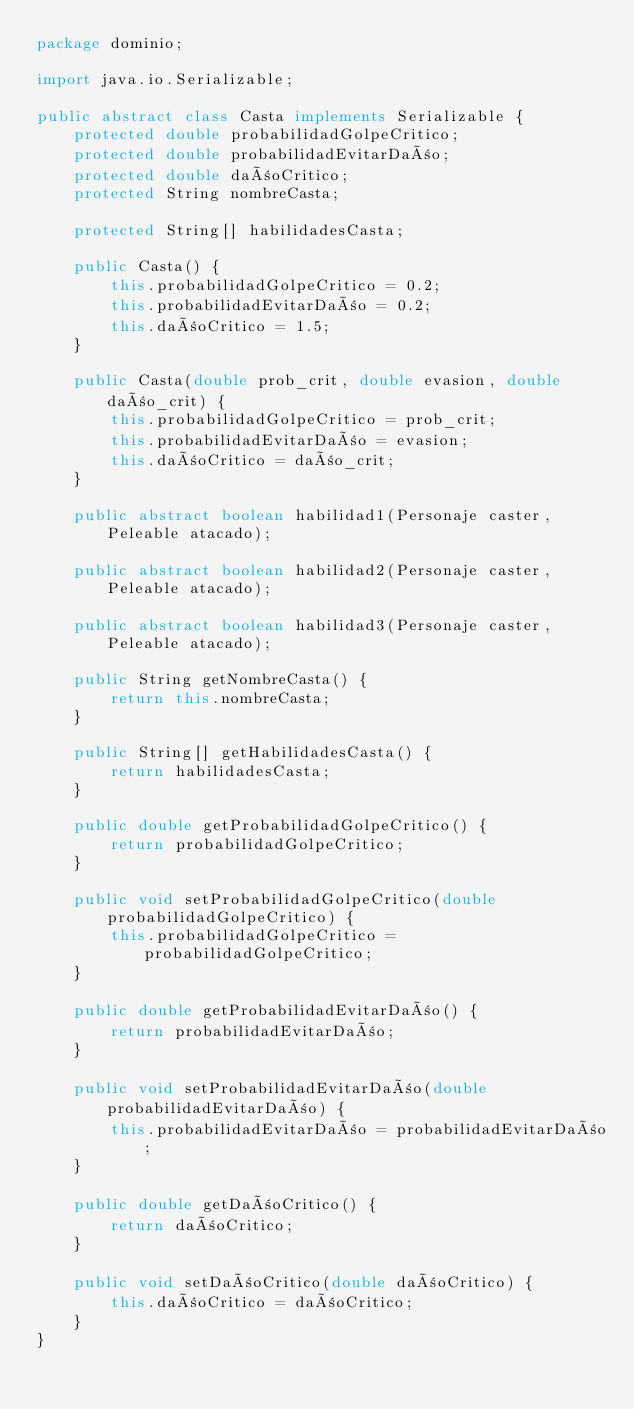Convert code to text. <code><loc_0><loc_0><loc_500><loc_500><_Java_>package dominio;

import java.io.Serializable;

public abstract class Casta implements Serializable {
	protected double probabilidadGolpeCritico;
	protected double probabilidadEvitarDaño;
	protected double dañoCritico;
	protected String nombreCasta;

	protected String[] habilidadesCasta;

	public Casta() {
		this.probabilidadGolpeCritico = 0.2;
		this.probabilidadEvitarDaño = 0.2;
		this.dañoCritico = 1.5;
	}

	public Casta(double prob_crit, double evasion, double daño_crit) {
		this.probabilidadGolpeCritico = prob_crit;
		this.probabilidadEvitarDaño = evasion;
		this.dañoCritico = daño_crit;
	}

	public abstract boolean habilidad1(Personaje caster, Peleable atacado);

	public abstract boolean habilidad2(Personaje caster, Peleable atacado);

	public abstract boolean habilidad3(Personaje caster, Peleable atacado);

	public String getNombreCasta() {
		return this.nombreCasta;
	}

	public String[] getHabilidadesCasta() {
		return habilidadesCasta;
	}

	public double getProbabilidadGolpeCritico() {
		return probabilidadGolpeCritico;
	}

	public void setProbabilidadGolpeCritico(double probabilidadGolpeCritico) {
		this.probabilidadGolpeCritico = probabilidadGolpeCritico;
	}

	public double getProbabilidadEvitarDaño() {
		return probabilidadEvitarDaño;
	}

	public void setProbabilidadEvitarDaño(double probabilidadEvitarDaño) {
		this.probabilidadEvitarDaño = probabilidadEvitarDaño;
	}

	public double getDañoCritico() {
		return dañoCritico;
	}

	public void setDañoCritico(double dañoCritico) {
		this.dañoCritico = dañoCritico;
	}
}
</code> 